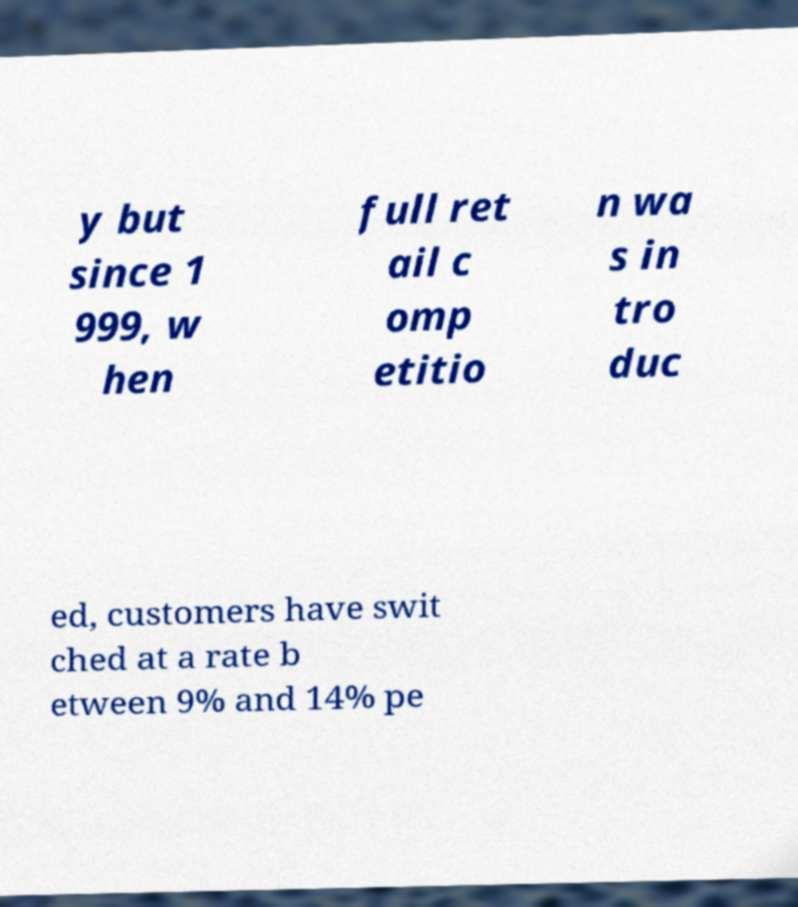Please read and relay the text visible in this image. What does it say? y but since 1 999, w hen full ret ail c omp etitio n wa s in tro duc ed, customers have swit ched at a rate b etween 9% and 14% pe 